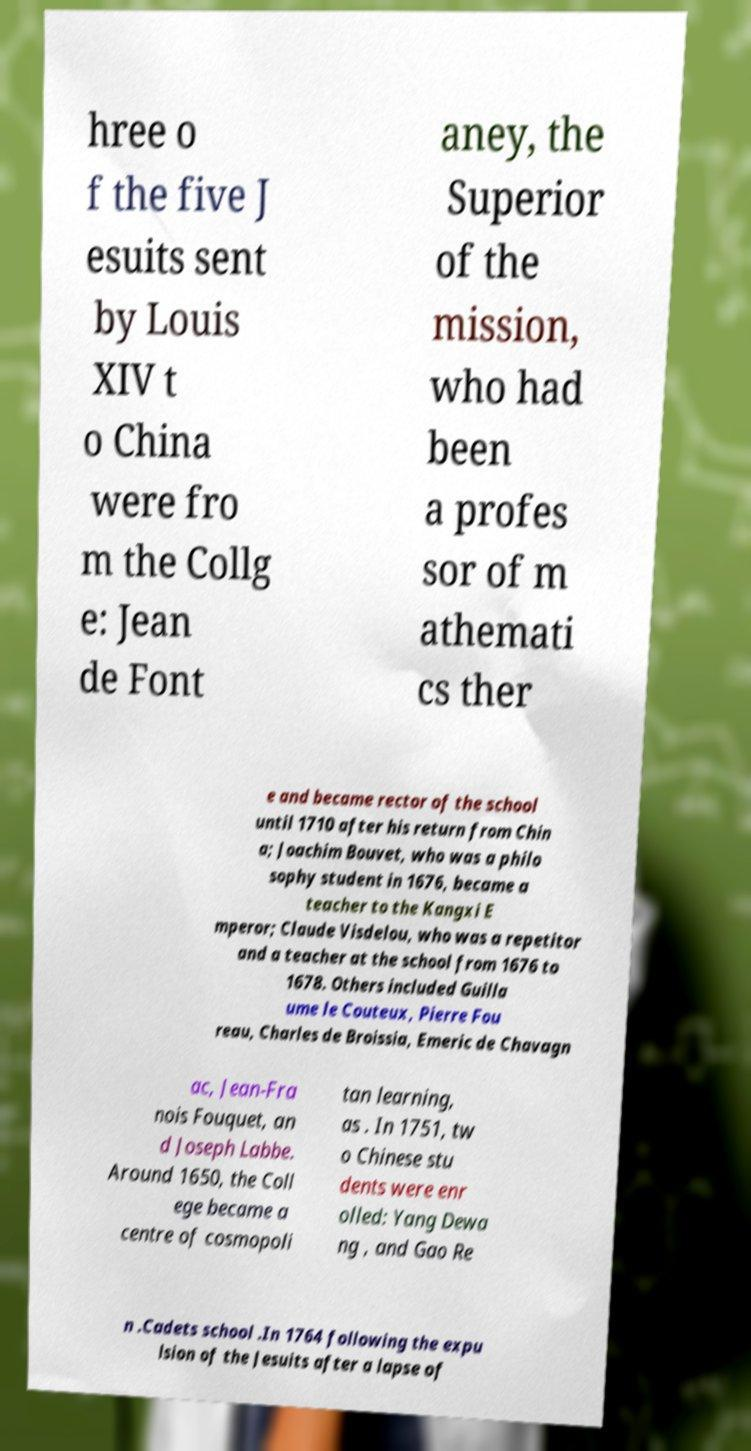Please identify and transcribe the text found in this image. hree o f the five J esuits sent by Louis XIV t o China were fro m the Collg e: Jean de Font aney, the Superior of the mission, who had been a profes sor of m athemati cs ther e and became rector of the school until 1710 after his return from Chin a; Joachim Bouvet, who was a philo sophy student in 1676, became a teacher to the Kangxi E mperor; Claude Visdelou, who was a repetitor and a teacher at the school from 1676 to 1678. Others included Guilla ume le Couteux, Pierre Fou reau, Charles de Broissia, Emeric de Chavagn ac, Jean-Fra nois Fouquet, an d Joseph Labbe. Around 1650, the Coll ege became a centre of cosmopoli tan learning, as . In 1751, tw o Chinese stu dents were enr olled: Yang Dewa ng , and Gao Re n .Cadets school .In 1764 following the expu lsion of the Jesuits after a lapse of 